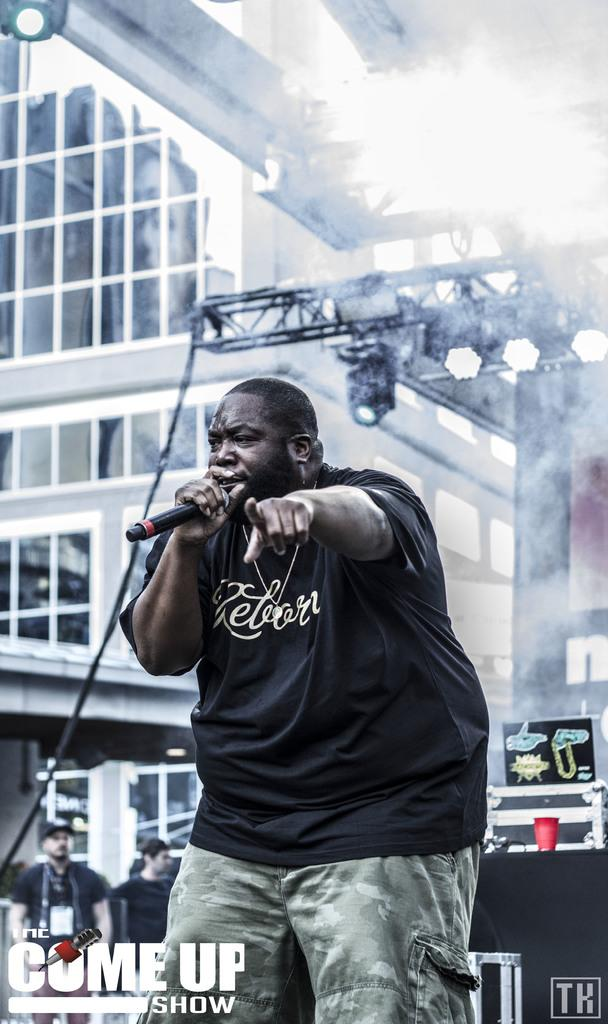What is the main subject of the image? The main subject of the image is a man. What is the man wearing in the image? The man is wearing a black t-shirt in the image. What is the man holding in the image? The man is holding a microphone in the image. What can be seen in the background of the image? There are people and lights visible in the background of the image. What type of bubble can be seen floating near the man in the image? There is no bubble present in the image; it only features a man holding a microphone, people, and lights in the background. 